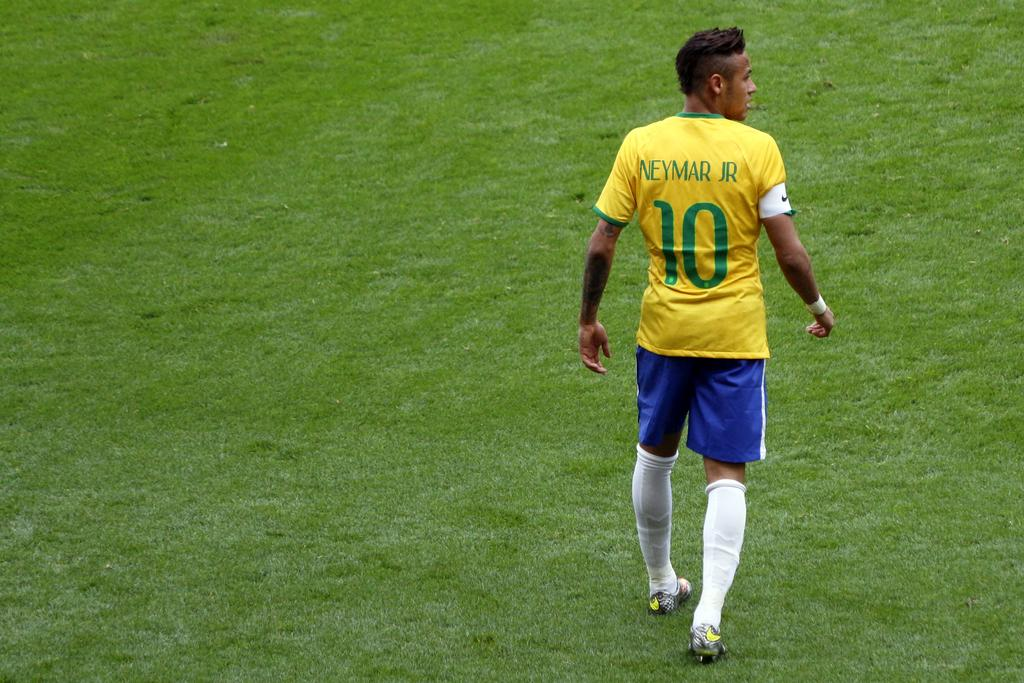<image>
Provide a brief description of the given image. Player number 10 walks across the grassy field. 